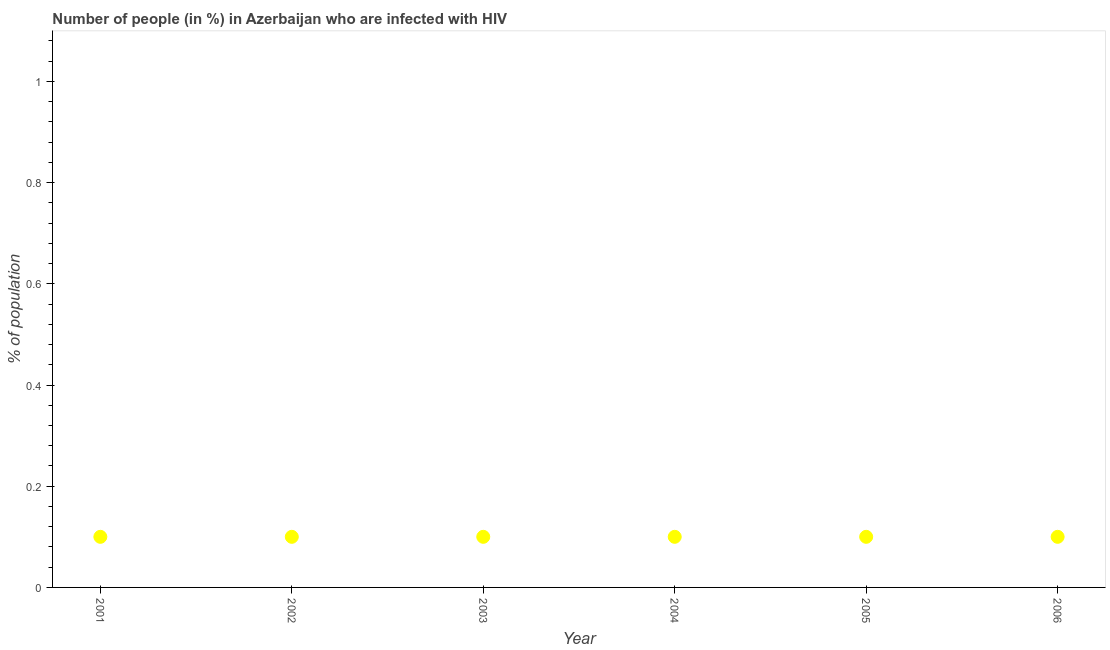What is the number of people infected with hiv in 2003?
Provide a short and direct response. 0.1. Across all years, what is the minimum number of people infected with hiv?
Give a very brief answer. 0.1. In which year was the number of people infected with hiv maximum?
Provide a short and direct response. 2001. What is the average number of people infected with hiv per year?
Your answer should be very brief. 0.1. In how many years, is the number of people infected with hiv greater than 0.9600000000000001 %?
Keep it short and to the point. 0. Do a majority of the years between 2001 and 2004 (inclusive) have number of people infected with hiv greater than 0.32 %?
Offer a very short reply. No. What is the ratio of the number of people infected with hiv in 2002 to that in 2003?
Make the answer very short. 1. What is the difference between the highest and the second highest number of people infected with hiv?
Keep it short and to the point. 0. How many years are there in the graph?
Make the answer very short. 6. Are the values on the major ticks of Y-axis written in scientific E-notation?
Ensure brevity in your answer.  No. Does the graph contain grids?
Ensure brevity in your answer.  No. What is the title of the graph?
Provide a succinct answer. Number of people (in %) in Azerbaijan who are infected with HIV. What is the label or title of the X-axis?
Your answer should be very brief. Year. What is the label or title of the Y-axis?
Keep it short and to the point. % of population. What is the % of population in 2002?
Make the answer very short. 0.1. What is the % of population in 2003?
Provide a succinct answer. 0.1. What is the % of population in 2004?
Keep it short and to the point. 0.1. What is the difference between the % of population in 2001 and 2002?
Give a very brief answer. 0. What is the difference between the % of population in 2001 and 2003?
Provide a short and direct response. 0. What is the difference between the % of population in 2001 and 2004?
Make the answer very short. 0. What is the difference between the % of population in 2002 and 2003?
Ensure brevity in your answer.  0. What is the difference between the % of population in 2002 and 2005?
Your answer should be compact. 0. What is the difference between the % of population in 2003 and 2004?
Make the answer very short. 0. What is the difference between the % of population in 2003 and 2006?
Offer a terse response. 0. What is the difference between the % of population in 2004 and 2005?
Give a very brief answer. 0. What is the difference between the % of population in 2004 and 2006?
Your answer should be very brief. 0. What is the difference between the % of population in 2005 and 2006?
Make the answer very short. 0. What is the ratio of the % of population in 2001 to that in 2002?
Your answer should be very brief. 1. What is the ratio of the % of population in 2001 to that in 2005?
Make the answer very short. 1. What is the ratio of the % of population in 2002 to that in 2005?
Ensure brevity in your answer.  1. What is the ratio of the % of population in 2002 to that in 2006?
Ensure brevity in your answer.  1. What is the ratio of the % of population in 2003 to that in 2004?
Your answer should be very brief. 1. What is the ratio of the % of population in 2003 to that in 2005?
Your response must be concise. 1. What is the ratio of the % of population in 2005 to that in 2006?
Your answer should be very brief. 1. 